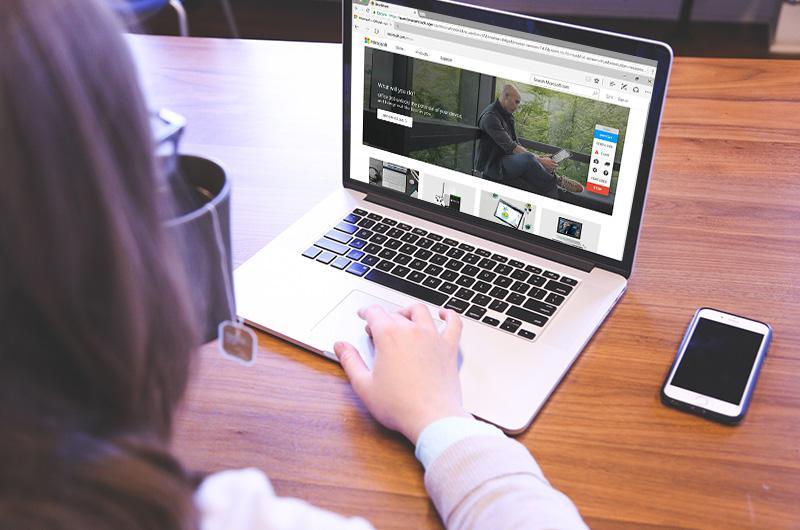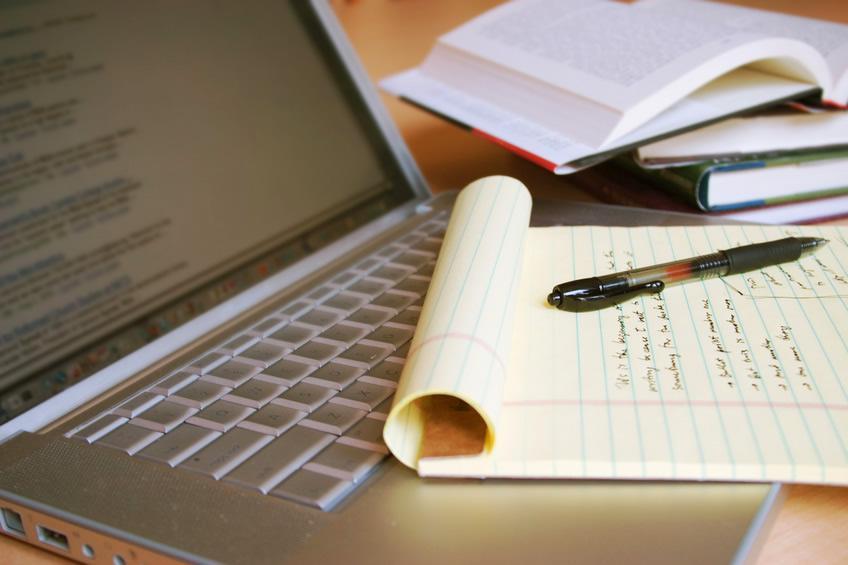The first image is the image on the left, the second image is the image on the right. Assess this claim about the two images: "A pen is on flat paper by a laptop screen and stacked paper materials in the right image, and the left image includes at least one hand on the base of an open laptop.". Correct or not? Answer yes or no. Yes. The first image is the image on the left, the second image is the image on the right. Examine the images to the left and right. Is the description "There is one cup in the right image." accurate? Answer yes or no. No. 